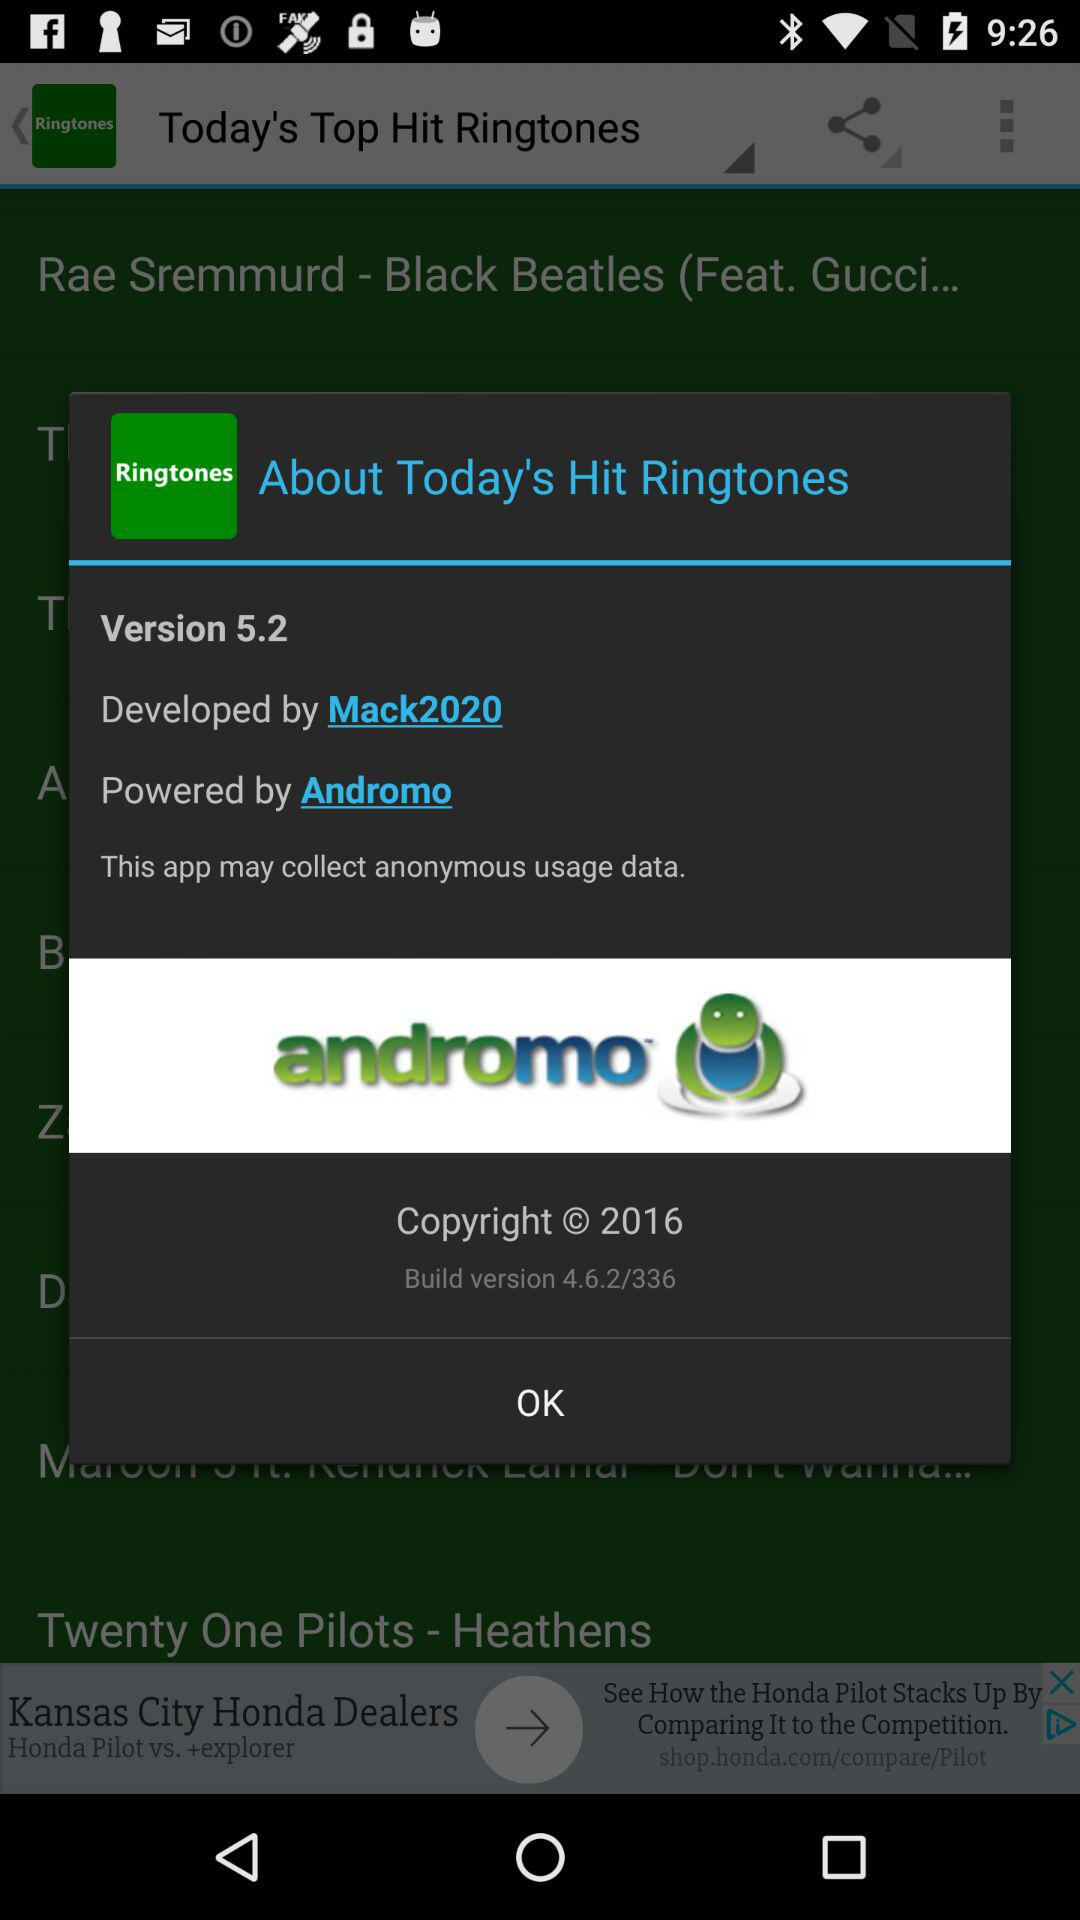What is the name of application? The name of application is "Today's Top Hit Ringtones". 